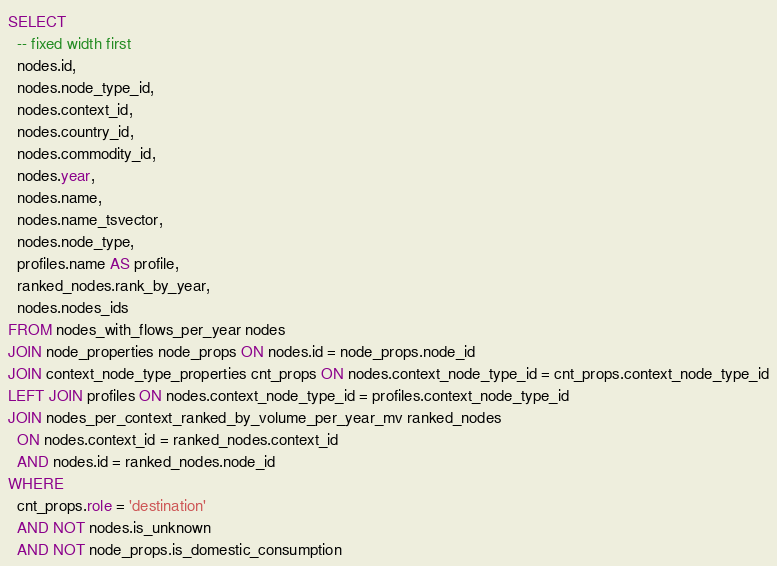<code> <loc_0><loc_0><loc_500><loc_500><_SQL_>SELECT
  -- fixed width first
  nodes.id,
  nodes.node_type_id,
  nodes.context_id,
  nodes.country_id,
  nodes.commodity_id,
  nodes.year,
  nodes.name,
  nodes.name_tsvector,
  nodes.node_type,
  profiles.name AS profile,
  ranked_nodes.rank_by_year,
  nodes.nodes_ids
FROM nodes_with_flows_per_year nodes
JOIN node_properties node_props ON nodes.id = node_props.node_id
JOIN context_node_type_properties cnt_props ON nodes.context_node_type_id = cnt_props.context_node_type_id
LEFT JOIN profiles ON nodes.context_node_type_id = profiles.context_node_type_id
JOIN nodes_per_context_ranked_by_volume_per_year_mv ranked_nodes
  ON nodes.context_id = ranked_nodes.context_id
  AND nodes.id = ranked_nodes.node_id
WHERE
  cnt_props.role = 'destination'
  AND NOT nodes.is_unknown
  AND NOT node_props.is_domestic_consumption</code> 